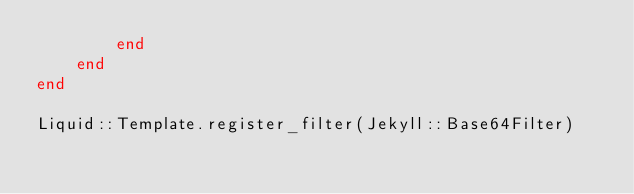Convert code to text. <code><loc_0><loc_0><loc_500><loc_500><_Ruby_>        end
    end
end

Liquid::Template.register_filter(Jekyll::Base64Filter)
</code> 